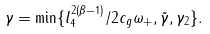Convert formula to latex. <formula><loc_0><loc_0><loc_500><loc_500>\gamma = \min \{ l _ { 4 } ^ { 2 ( \beta - 1 ) } / 2 c _ { g } \omega _ { + } , \tilde { \gamma } , \gamma _ { 2 } \} .</formula> 